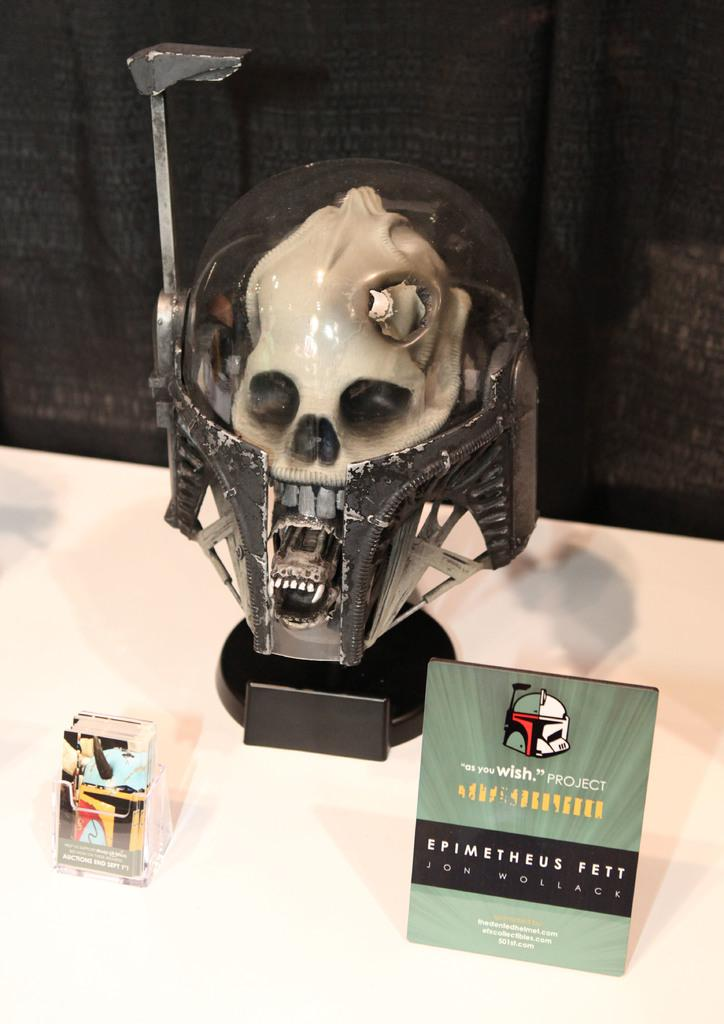What is the main subject of the image? There is a depiction of a person in the image. What else can be seen in the image besides the person? There are objects on a table in the image, and curtains behind the table. What caption is written below the person in the image? There is no caption present in the image; it is a visual depiction without any accompanying text. 